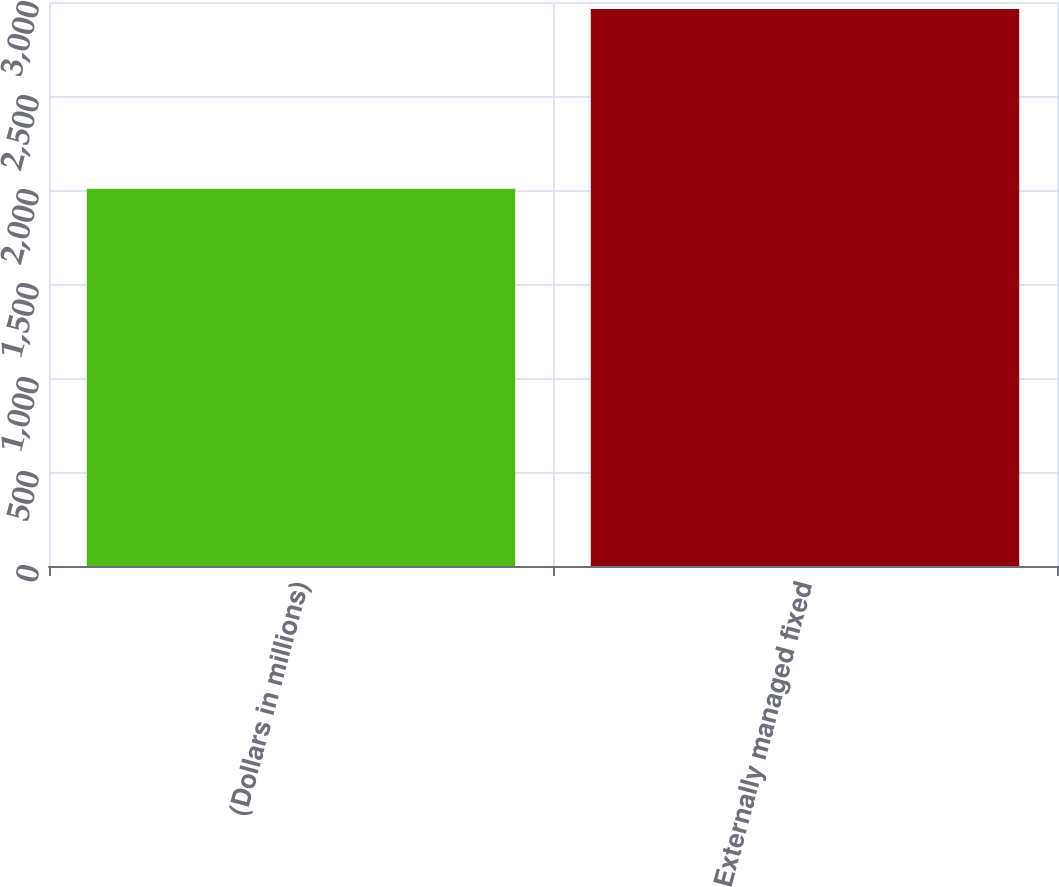<chart> <loc_0><loc_0><loc_500><loc_500><bar_chart><fcel>(Dollars in millions)<fcel>Externally managed fixed<nl><fcel>2007<fcel>2963<nl></chart> 